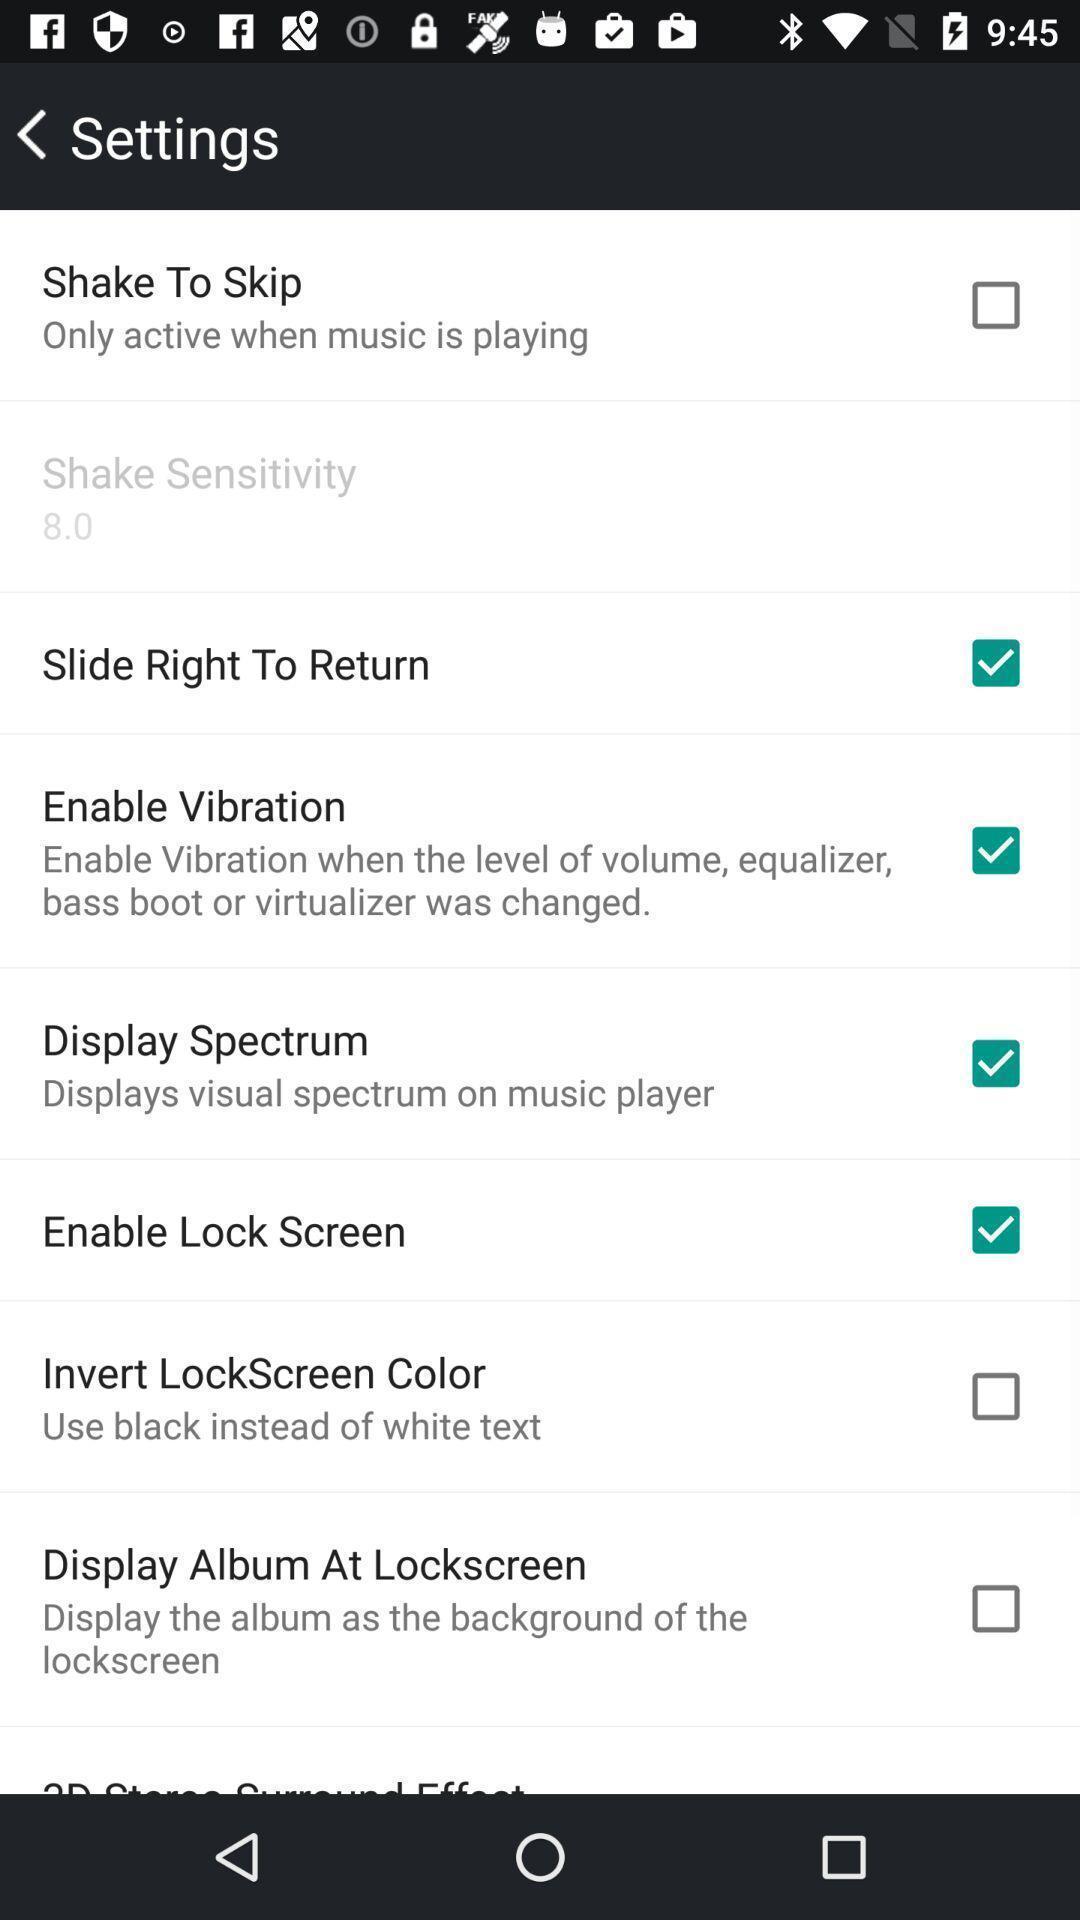Explain the elements present in this screenshot. Settings page with various options to enable or disable. 